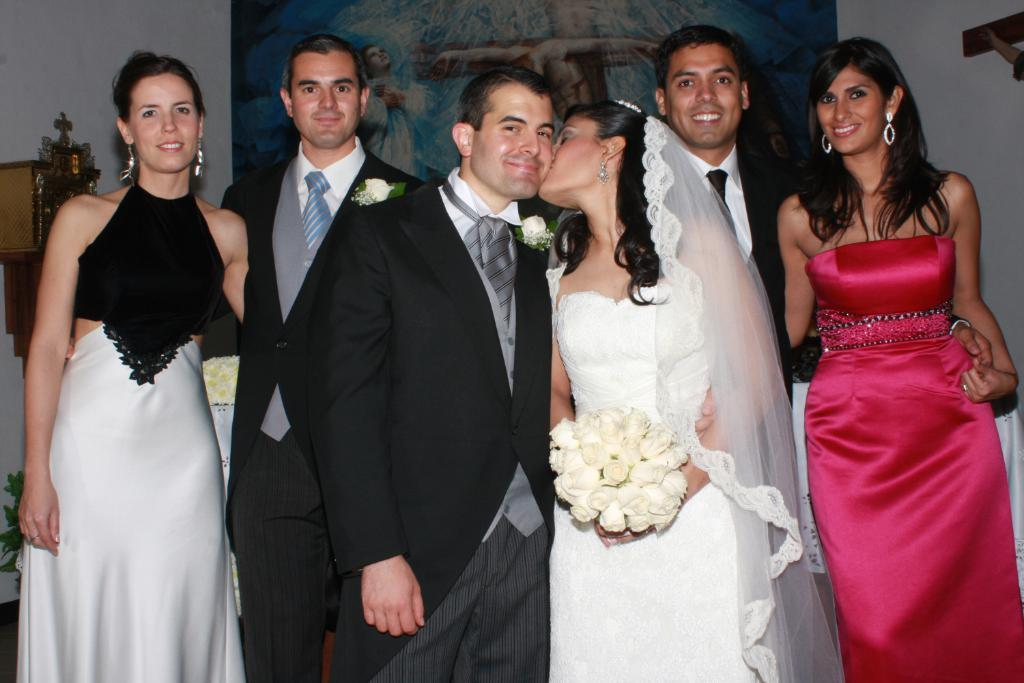How many people are in the image? There is a group of people standing in the image. What is the woman holding in the image? The woman is holding a bouquet. What type of object can be seen in the image that is related to plants? There is a plant in the image. What type of object can be seen in the image that is related to art or decoration? There is a statue in the image. What type of object can be seen in the image that is related to visual representation? There is a picture in the image. What type of object can be seen in the image that is related to storage or display? There is a wooden box on a wall in the image. Can you tell me how many kittens are playing on the wooden box in the image? There are no kittens present in the image; the wooden box is on a wall. What type of slip is the woman wearing in the image? The image does not provide information about the woman's clothing. 